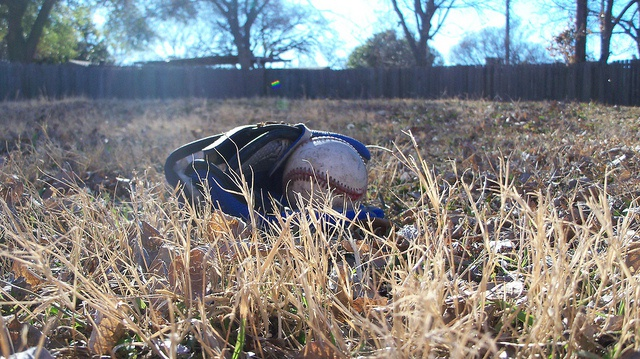Describe the objects in this image and their specific colors. I can see baseball glove in darkblue, black, navy, gray, and darkgray tones and sports ball in darkblue, gray, and black tones in this image. 